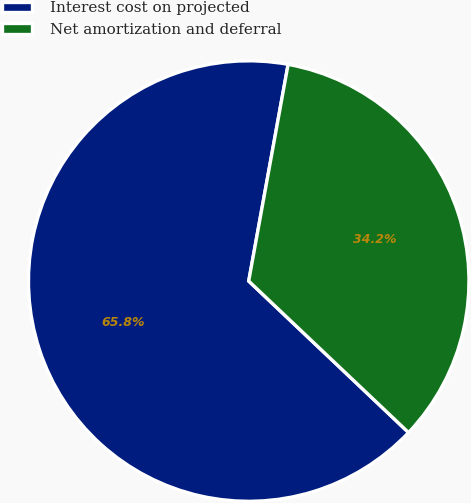Convert chart to OTSL. <chart><loc_0><loc_0><loc_500><loc_500><pie_chart><fcel>Interest cost on projected<fcel>Net amortization and deferral<nl><fcel>65.79%<fcel>34.21%<nl></chart> 